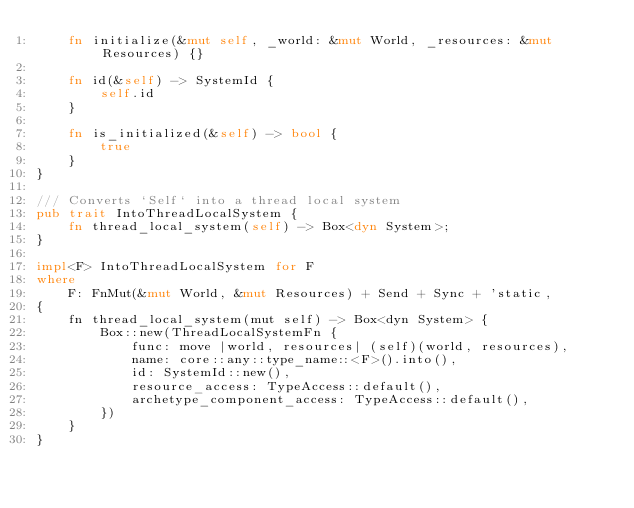Convert code to text. <code><loc_0><loc_0><loc_500><loc_500><_Rust_>    fn initialize(&mut self, _world: &mut World, _resources: &mut Resources) {}

    fn id(&self) -> SystemId {
        self.id
    }

    fn is_initialized(&self) -> bool {
        true
    }
}

/// Converts `Self` into a thread local system
pub trait IntoThreadLocalSystem {
    fn thread_local_system(self) -> Box<dyn System>;
}

impl<F> IntoThreadLocalSystem for F
where
    F: FnMut(&mut World, &mut Resources) + Send + Sync + 'static,
{
    fn thread_local_system(mut self) -> Box<dyn System> {
        Box::new(ThreadLocalSystemFn {
            func: move |world, resources| (self)(world, resources),
            name: core::any::type_name::<F>().into(),
            id: SystemId::new(),
            resource_access: TypeAccess::default(),
            archetype_component_access: TypeAccess::default(),
        })
    }
}
</code> 